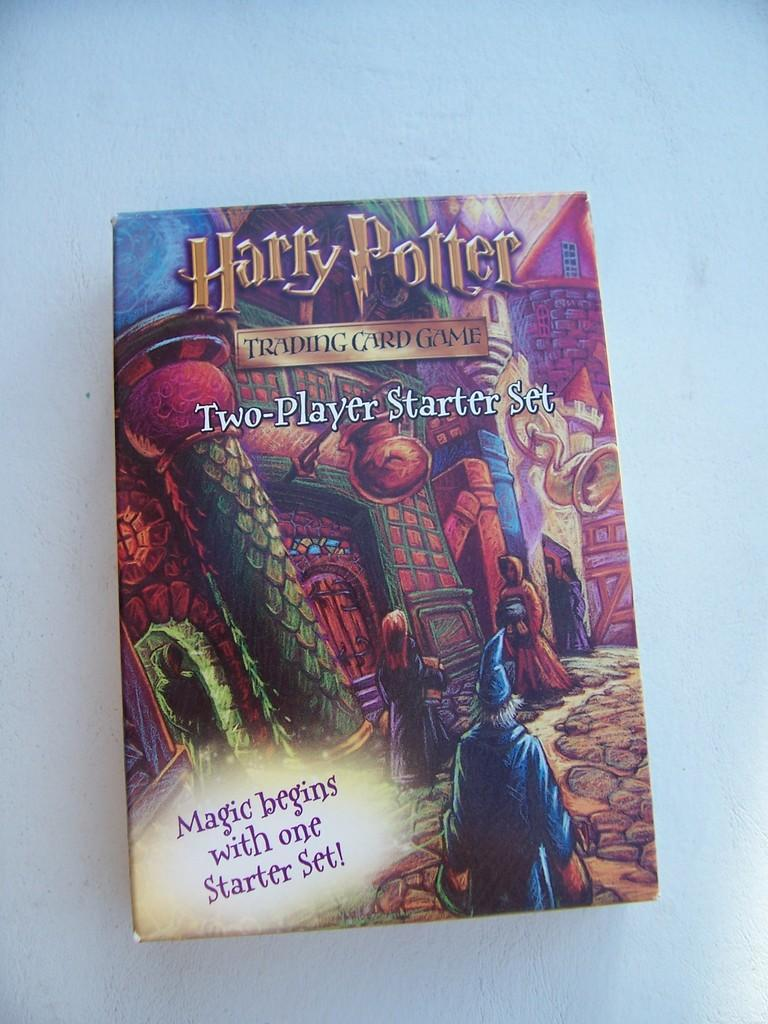<image>
Summarize the visual content of the image. the cover of a harry potter trading card game box 